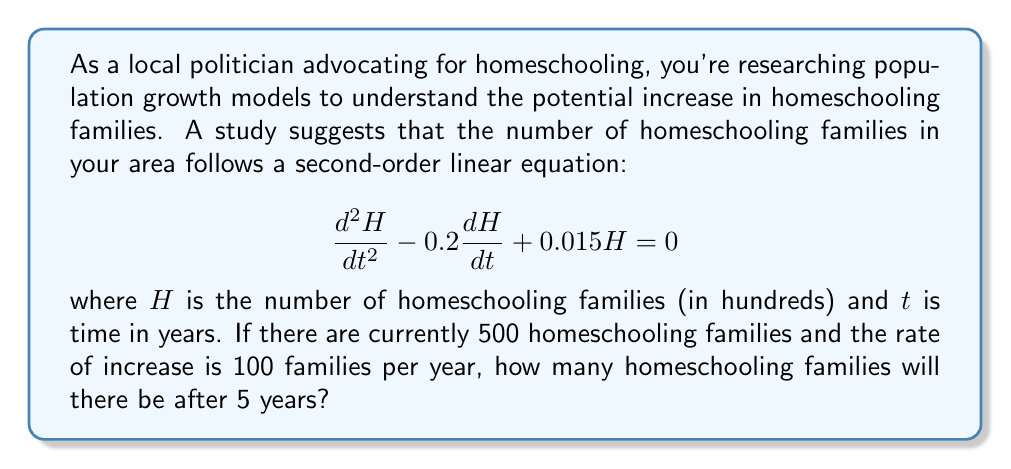Show me your answer to this math problem. To solve this problem, we need to follow these steps:

1) First, we need to find the general solution of the given second-order linear equation:

   $$\frac{d^2H}{dt^2} - 0.2\frac{dH}{dt} + 0.015H = 0$$

   The characteristic equation is:
   $$r^2 - 0.2r + 0.015 = 0$$

   Solving this quadratic equation:
   $$r = \frac{0.2 \pm \sqrt{0.04 - 0.06}}{2} = \frac{0.2 \pm \sqrt{-0.02}}{2} = 0.1 \pm 0.1i$$

   Therefore, the general solution is:
   $$H(t) = e^{0.1t}(C_1\cos(0.1t) + C_2\sin(0.1t))$$

2) Now we need to use the initial conditions to find $C_1$ and $C_2$:
   
   At $t=0$, $H(0) = 5$ (500 families = 5 hundreds)
   $$5 = C_1$$

   At $t=0$, $H'(0) = 1$ (100 families/year = 1 hundred/year)
   $$1 = 0.1C_1 + 0.1C_2$$
   $$1 = 0.1(5) + 0.1C_2$$
   $$C_2 = 5$$

3) So our particular solution is:
   $$H(t) = 5e^{0.1t}(\cos(0.1t) + \sin(0.1t))$$

4) To find $H(5)$, we simply plug in $t=5$:
   $$H(5) = 5e^{0.5}(\cos(0.5) + \sin(0.5))$$
   $$= 5(1.6487)(0.8776 + 0.4794)$$
   $$= 5(1.6487)(1.3570)$$
   $$= 11.1786$$

5) Converting back to actual number of families:
   11.1786 hundreds = 1117.86 families
Answer: After 5 years, there will be approximately 1,118 homeschooling families. 